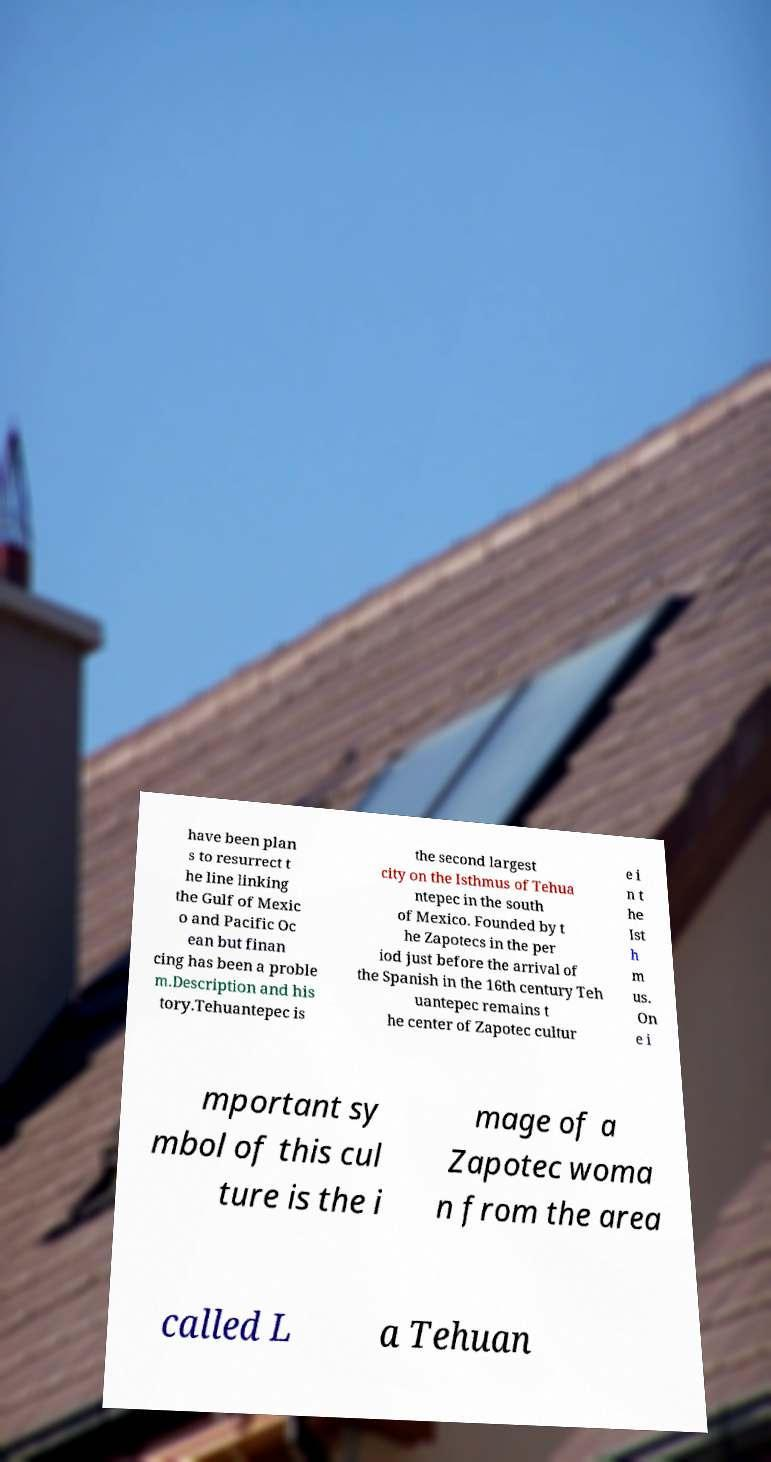Can you accurately transcribe the text from the provided image for me? have been plan s to resurrect t he line linking the Gulf of Mexic o and Pacific Oc ean but finan cing has been a proble m.Description and his tory.Tehuantepec is the second largest city on the Isthmus of Tehua ntepec in the south of Mexico. Founded by t he Zapotecs in the per iod just before the arrival of the Spanish in the 16th century Teh uantepec remains t he center of Zapotec cultur e i n t he Ist h m us. On e i mportant sy mbol of this cul ture is the i mage of a Zapotec woma n from the area called L a Tehuan 